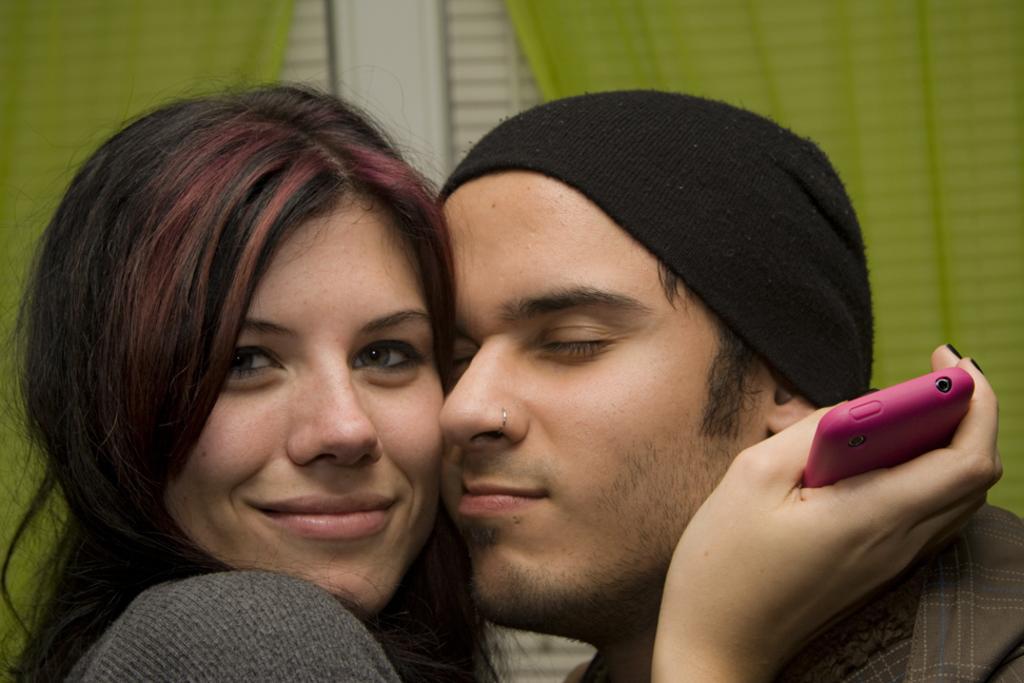How would you summarize this image in a sentence or two? In this picture we can see one girl and one boy girl is holding a mobile phone back side we can see green color cloth. 